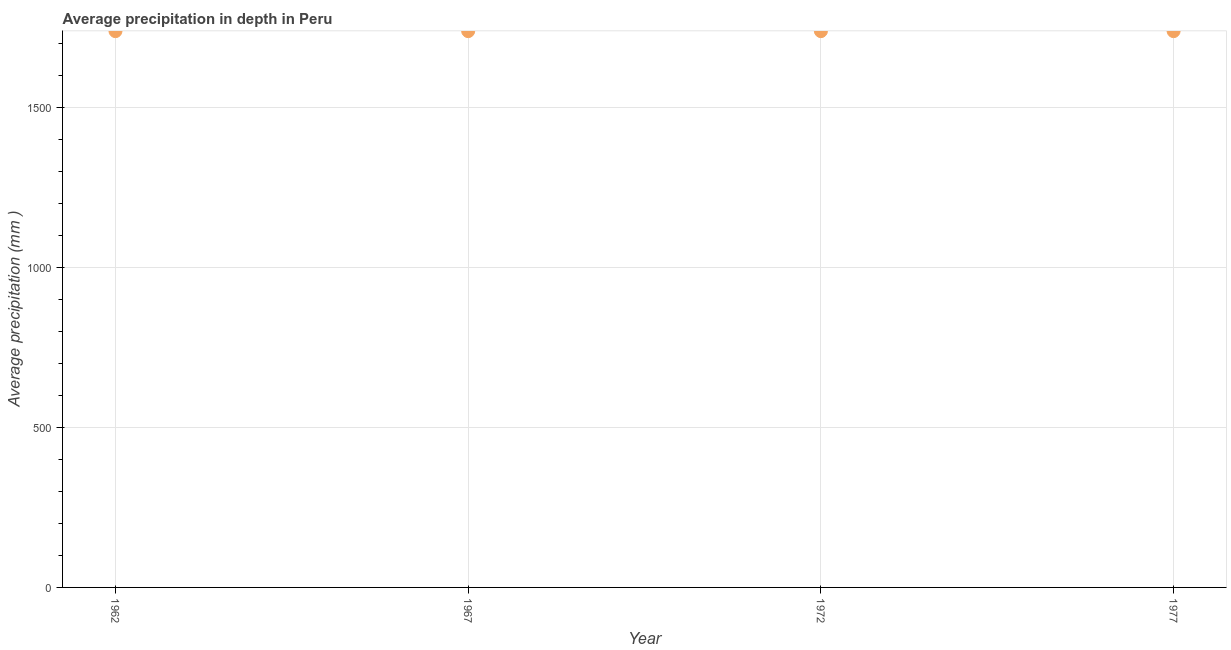What is the average precipitation in depth in 1962?
Offer a very short reply. 1738. Across all years, what is the maximum average precipitation in depth?
Offer a terse response. 1738. Across all years, what is the minimum average precipitation in depth?
Your response must be concise. 1738. In which year was the average precipitation in depth maximum?
Ensure brevity in your answer.  1962. In which year was the average precipitation in depth minimum?
Provide a succinct answer. 1962. What is the sum of the average precipitation in depth?
Give a very brief answer. 6952. What is the difference between the average precipitation in depth in 1962 and 1967?
Make the answer very short. 0. What is the average average precipitation in depth per year?
Your answer should be very brief. 1738. What is the median average precipitation in depth?
Keep it short and to the point. 1738. Is the sum of the average precipitation in depth in 1962 and 1972 greater than the maximum average precipitation in depth across all years?
Provide a succinct answer. Yes. What is the difference between the highest and the lowest average precipitation in depth?
Your response must be concise. 0. Does the average precipitation in depth monotonically increase over the years?
Provide a succinct answer. No. Are the values on the major ticks of Y-axis written in scientific E-notation?
Your answer should be very brief. No. Does the graph contain any zero values?
Your response must be concise. No. Does the graph contain grids?
Offer a terse response. Yes. What is the title of the graph?
Make the answer very short. Average precipitation in depth in Peru. What is the label or title of the Y-axis?
Make the answer very short. Average precipitation (mm ). What is the Average precipitation (mm ) in 1962?
Your answer should be compact. 1738. What is the Average precipitation (mm ) in 1967?
Provide a succinct answer. 1738. What is the Average precipitation (mm ) in 1972?
Ensure brevity in your answer.  1738. What is the Average precipitation (mm ) in 1977?
Your answer should be very brief. 1738. What is the difference between the Average precipitation (mm ) in 1962 and 1972?
Your response must be concise. 0. What is the ratio of the Average precipitation (mm ) in 1962 to that in 1972?
Your answer should be very brief. 1. What is the ratio of the Average precipitation (mm ) in 1967 to that in 1972?
Provide a short and direct response. 1. What is the ratio of the Average precipitation (mm ) in 1972 to that in 1977?
Keep it short and to the point. 1. 